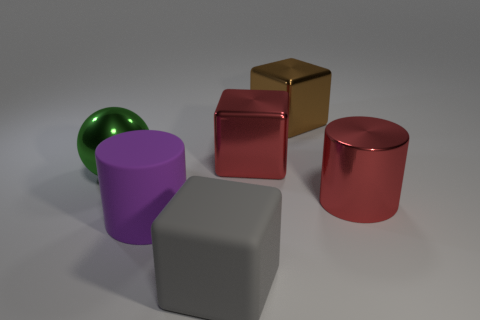Are there more large metallic blocks on the left side of the brown shiny block than big red metallic balls?
Offer a terse response. Yes. Is there a large rubber block that has the same color as the ball?
Your answer should be compact. No. There is a rubber cube that is the same size as the green ball; what color is it?
Make the answer very short. Gray. How many large metal spheres are behind the large red thing behind the green shiny thing?
Your answer should be compact. 0. What number of objects are either things to the right of the brown metal cube or large metal balls?
Make the answer very short. 2. How many big brown blocks have the same material as the gray block?
Your answer should be very brief. 0. The large metal thing that is the same color as the metal cylinder is what shape?
Offer a very short reply. Cube. Is the number of rubber objects that are in front of the large purple thing the same as the number of metallic spheres?
Make the answer very short. Yes. What is the size of the block in front of the large green metallic sphere?
Give a very brief answer. Large. What number of tiny objects are either red objects or yellow shiny spheres?
Your answer should be very brief. 0. 